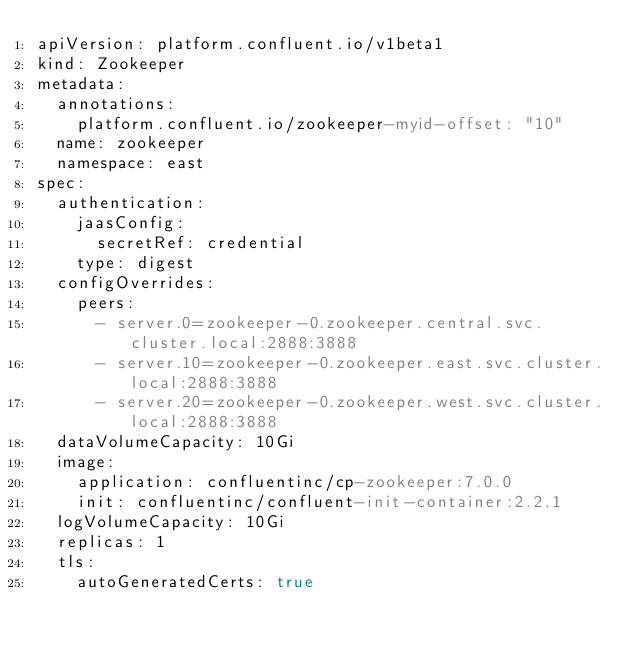Convert code to text. <code><loc_0><loc_0><loc_500><loc_500><_YAML_>apiVersion: platform.confluent.io/v1beta1
kind: Zookeeper
metadata:
  annotations:
    platform.confluent.io/zookeeper-myid-offset: "10"
  name: zookeeper
  namespace: east
spec:
  authentication:
    jaasConfig:
      secretRef: credential
    type: digest
  configOverrides:
    peers:
      - server.0=zookeeper-0.zookeeper.central.svc.cluster.local:2888:3888
      - server.10=zookeeper-0.zookeeper.east.svc.cluster.local:2888:3888
      - server.20=zookeeper-0.zookeeper.west.svc.cluster.local:2888:3888
  dataVolumeCapacity: 10Gi
  image:
    application: confluentinc/cp-zookeeper:7.0.0
    init: confluentinc/confluent-init-container:2.2.1
  logVolumeCapacity: 10Gi
  replicas: 1
  tls:
    autoGeneratedCerts: true</code> 